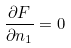Convert formula to latex. <formula><loc_0><loc_0><loc_500><loc_500>\frac { \partial F } { \partial n _ { 1 } } = 0</formula> 